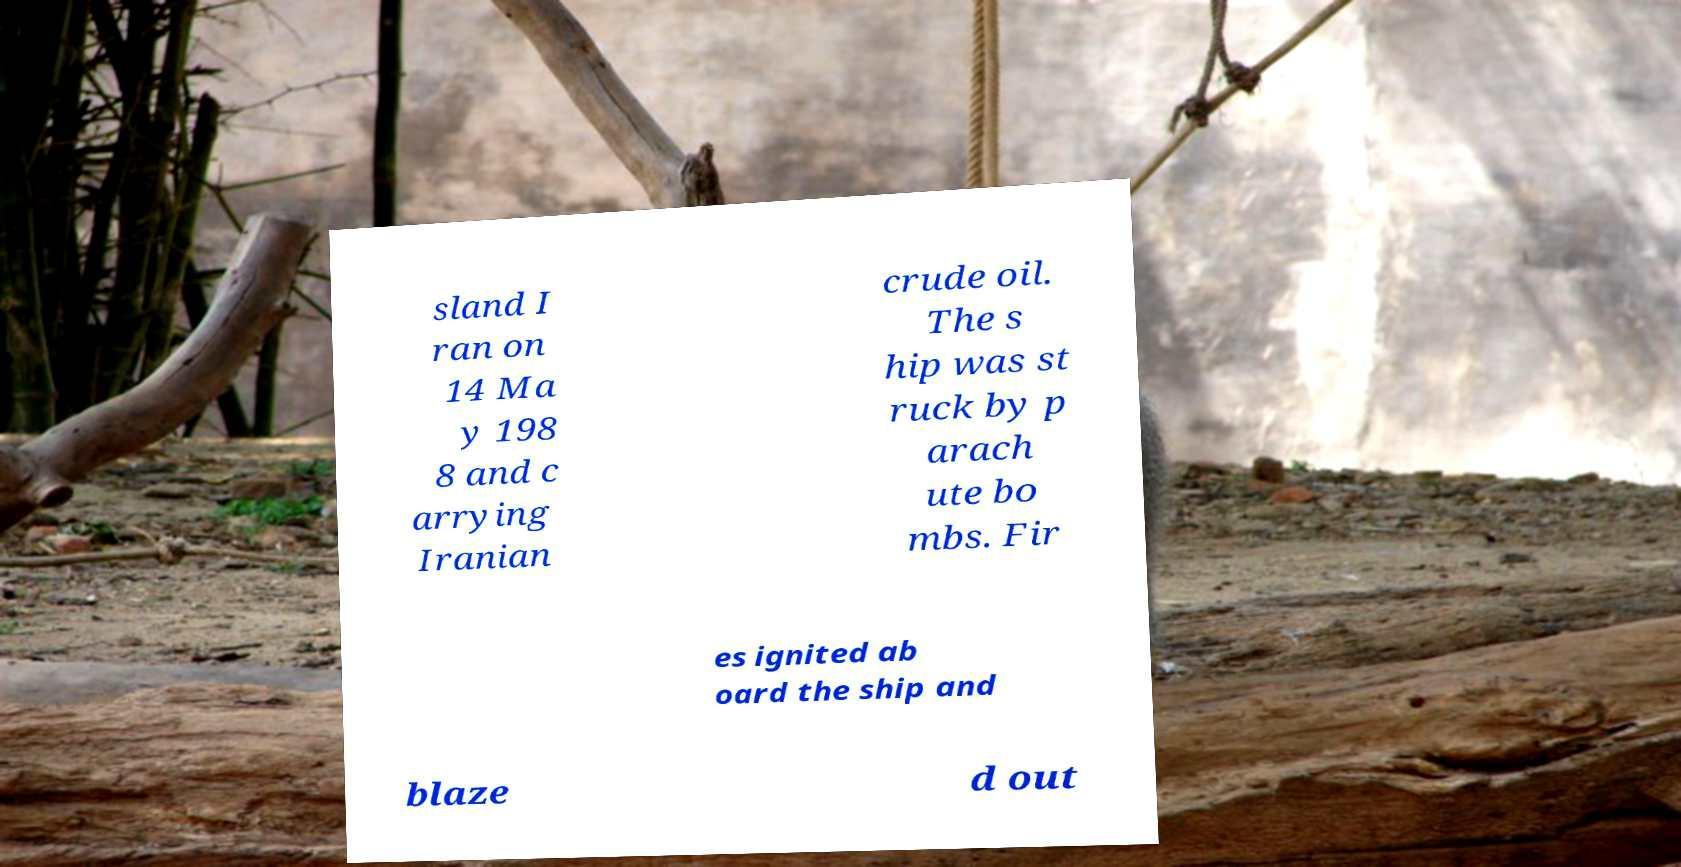Please identify and transcribe the text found in this image. sland I ran on 14 Ma y 198 8 and c arrying Iranian crude oil. The s hip was st ruck by p arach ute bo mbs. Fir es ignited ab oard the ship and blaze d out 